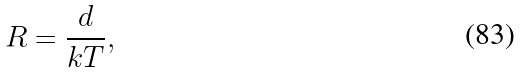Convert formula to latex. <formula><loc_0><loc_0><loc_500><loc_500>R = \frac { d } { k T } ,</formula> 